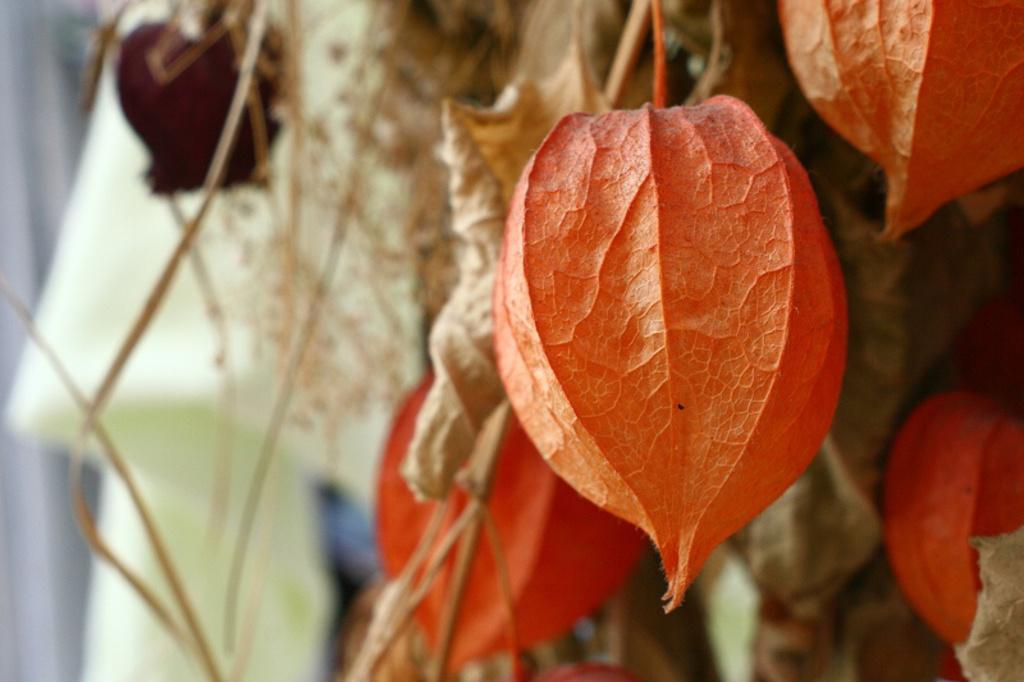What type of objects are present in the image? The image contains different types of leaves. What color are the leaves in the image? The leaves in the image are orange in color. Are there any leaves that appear to be in a different state than the others? Yes, there are dried leaves in the image. What else can be found among the leaves in the image? There are twigs in the image. How many legs can be seen on the steel structure in the image? There is no steel structure or legs present in the image; it features different types of leaves and twigs. 